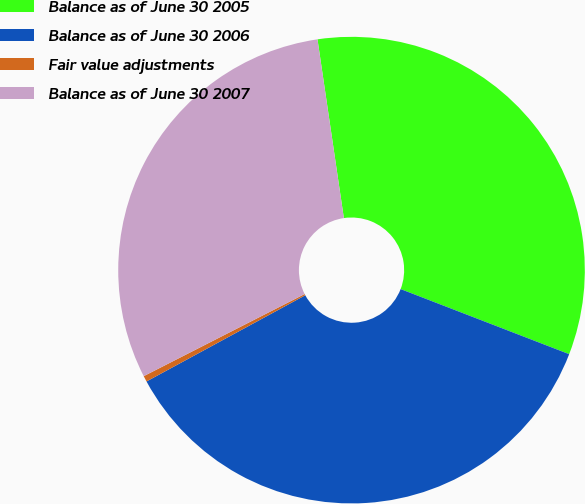<chart> <loc_0><loc_0><loc_500><loc_500><pie_chart><fcel>Balance as of June 30 2005<fcel>Balance as of June 30 2006<fcel>Fair value adjustments<fcel>Balance as of June 30 2007<nl><fcel>33.2%<fcel>36.22%<fcel>0.41%<fcel>30.18%<nl></chart> 